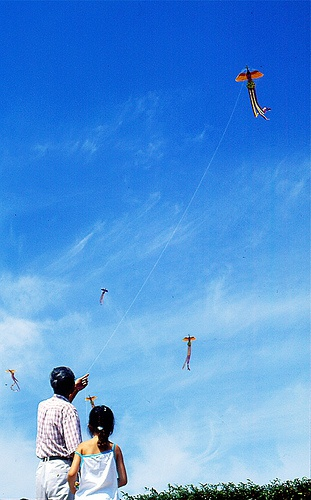Describe the objects in this image and their specific colors. I can see people in blue, white, black, darkgray, and lightblue tones, people in blue, white, black, darkgray, and lightblue tones, kite in blue, black, maroon, and red tones, kite in blue, lightblue, and gray tones, and kite in blue, gray, and darkgray tones in this image. 